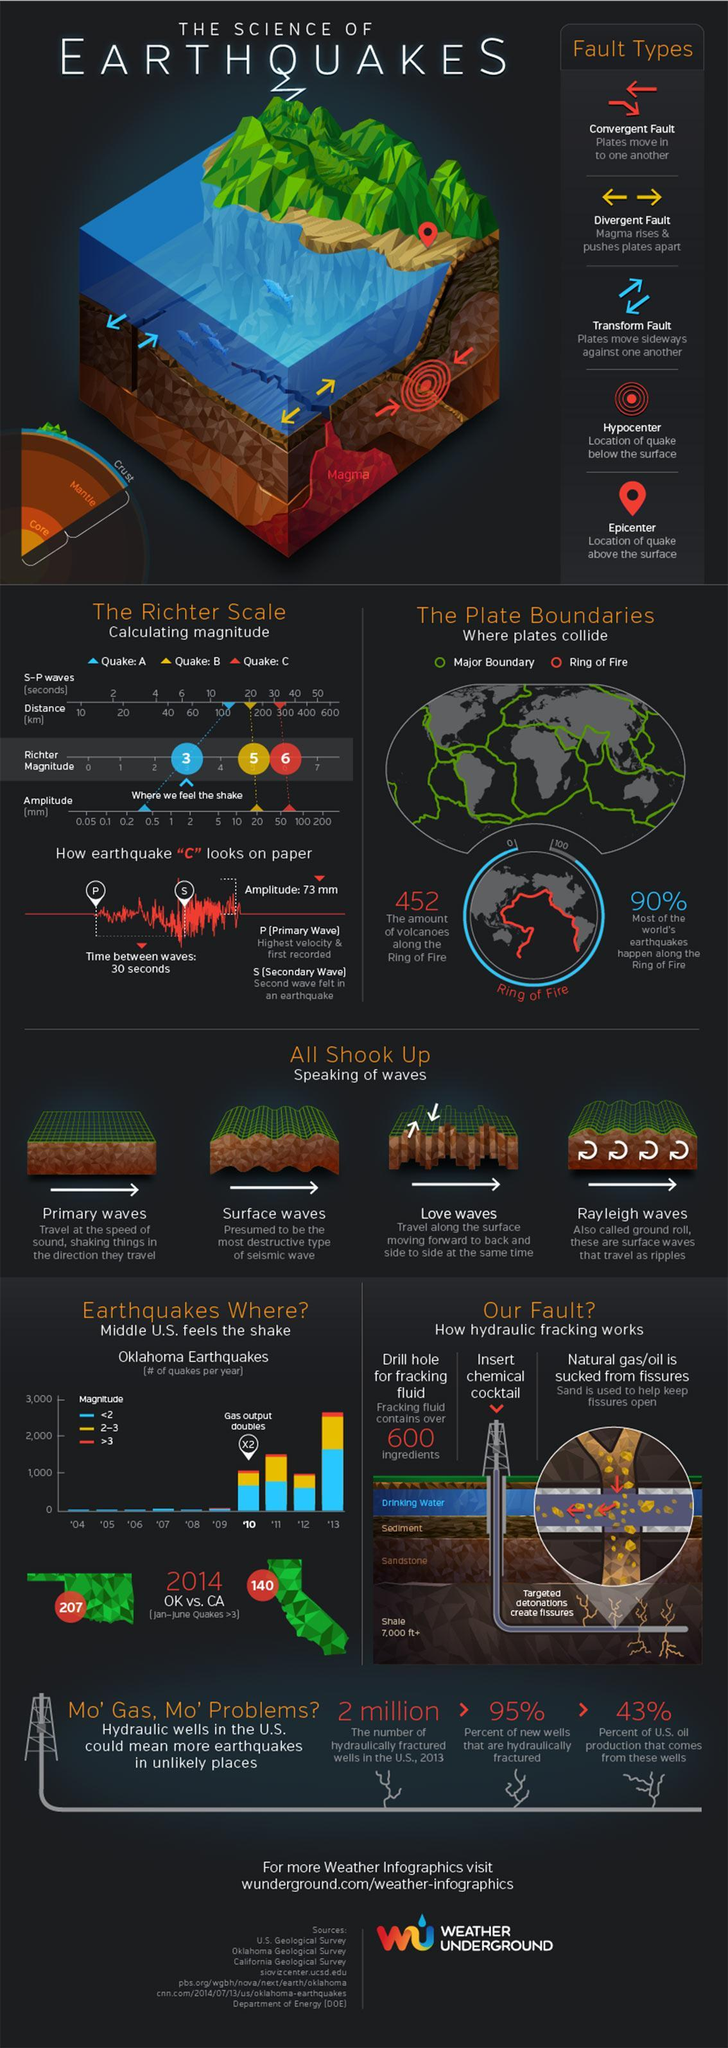What percentage of earthquakes occur not in the Ring of fire?
Answer the question with a short phrase. 10% Which wave is called Rayleigh waves? ground roll How many types of faults mentioned in this infographic? 5 How many types of waves mentioned in this infographic? 4 